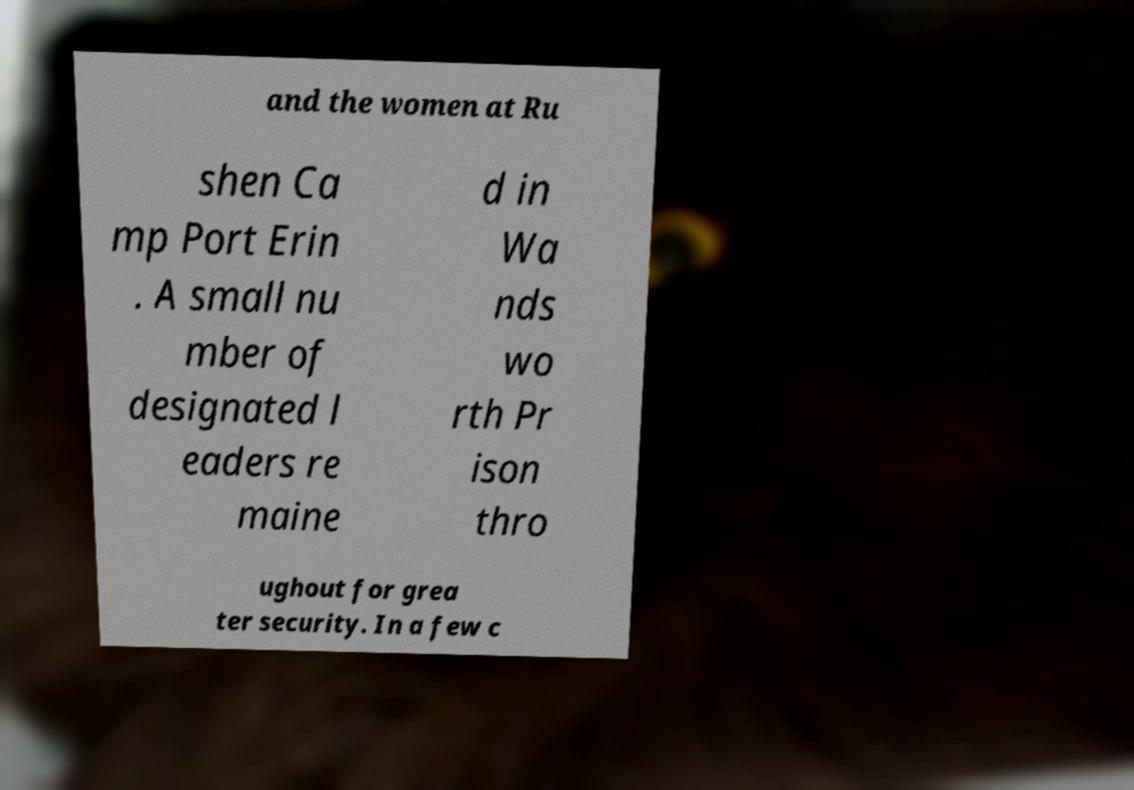There's text embedded in this image that I need extracted. Can you transcribe it verbatim? and the women at Ru shen Ca mp Port Erin . A small nu mber of designated l eaders re maine d in Wa nds wo rth Pr ison thro ughout for grea ter security. In a few c 